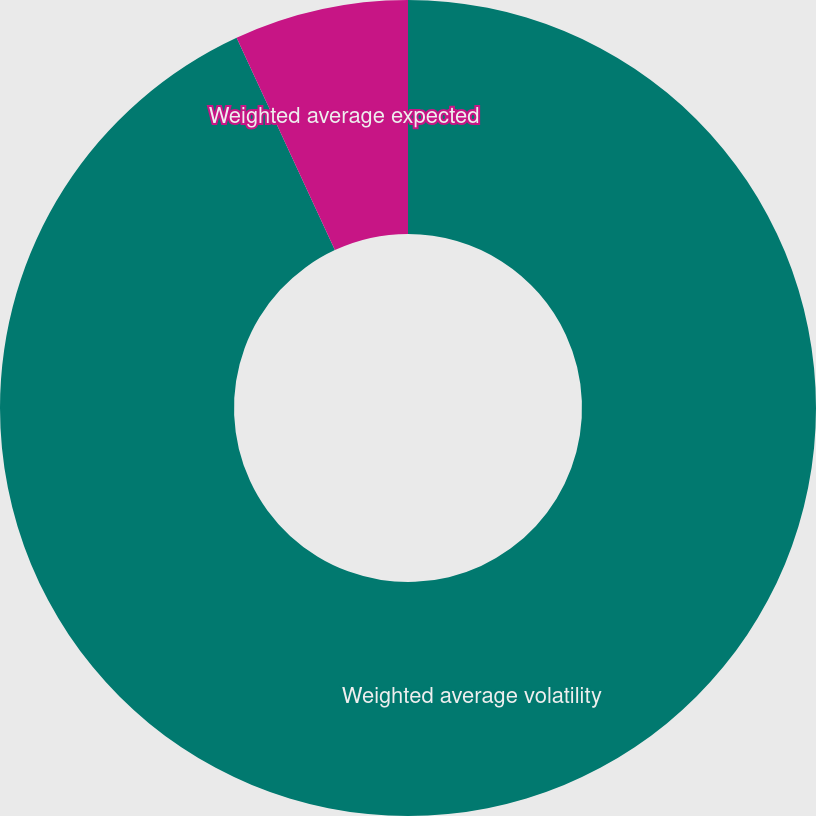Convert chart. <chart><loc_0><loc_0><loc_500><loc_500><pie_chart><fcel>Weighted average volatility<fcel>Weighted average expected<nl><fcel>93.1%<fcel>6.9%<nl></chart> 